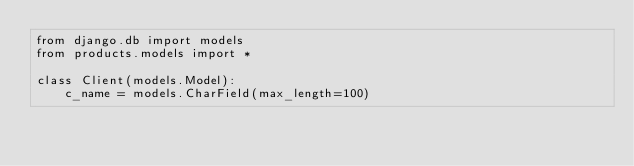<code> <loc_0><loc_0><loc_500><loc_500><_Python_>from django.db import models
from products.models import *

class Client(models.Model):
    c_name = models.CharField(max_length=100)</code> 